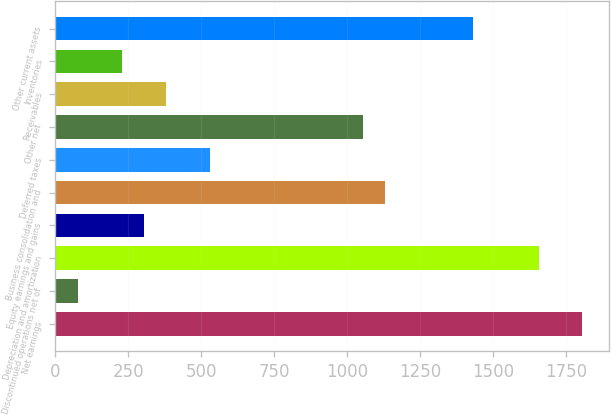<chart> <loc_0><loc_0><loc_500><loc_500><bar_chart><fcel>Net earnings<fcel>Discontinued operations net of<fcel>Depreciation and amortization<fcel>Equity earnings and gains<fcel>Business consolidation and<fcel>Deferred taxes<fcel>Other net<fcel>Receivables<fcel>Inventories<fcel>Other current assets<nl><fcel>1805.66<fcel>77.44<fcel>1655.38<fcel>302.86<fcel>1129.4<fcel>528.28<fcel>1054.26<fcel>378<fcel>227.72<fcel>1429.96<nl></chart> 